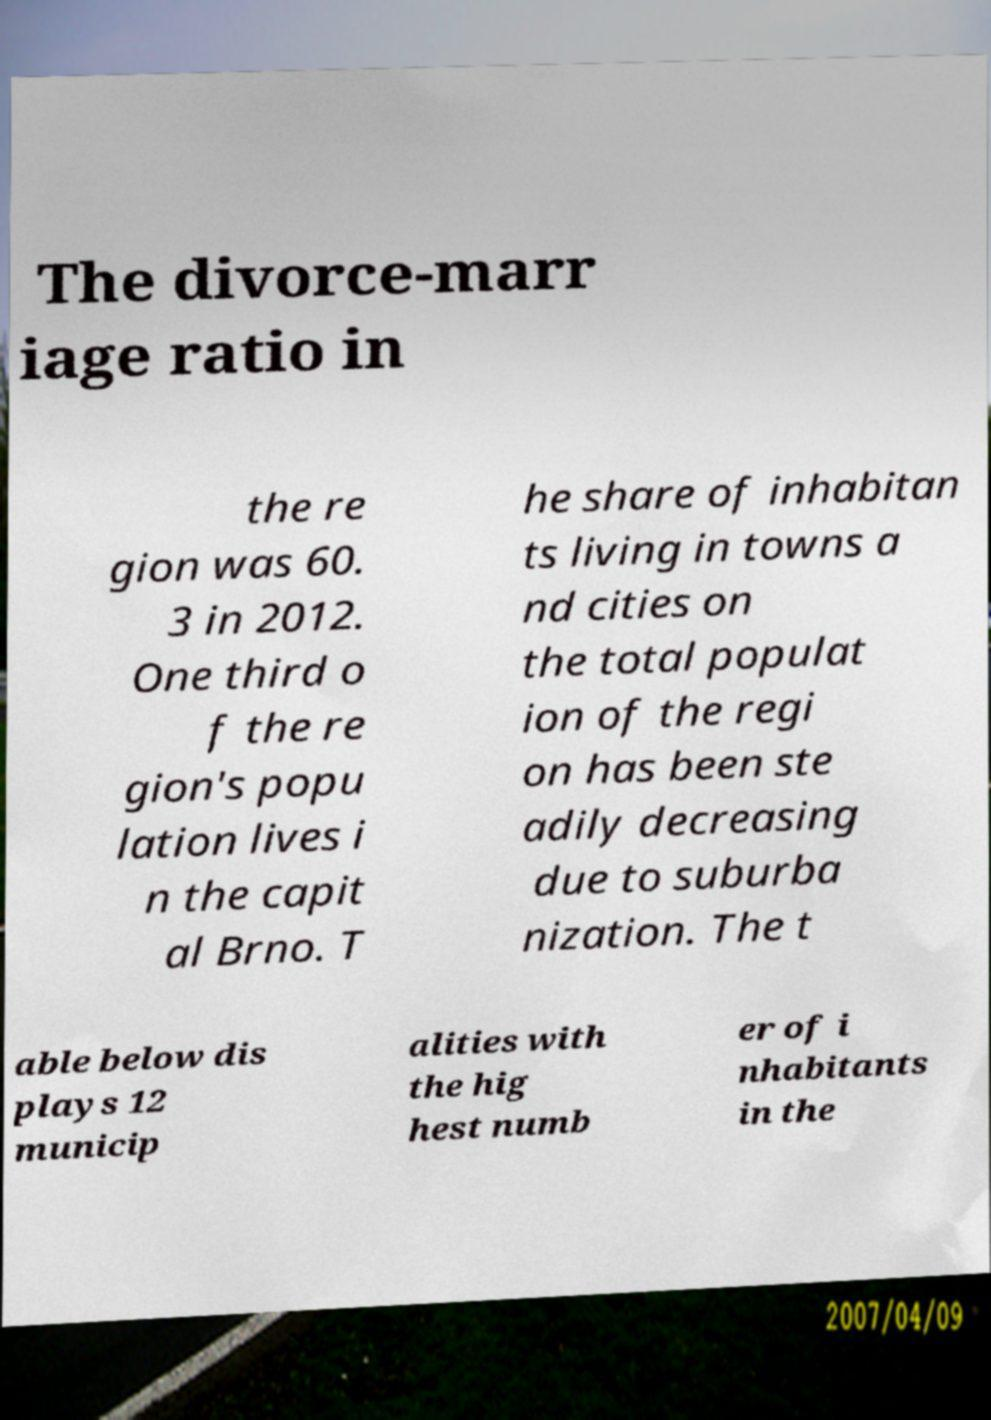For documentation purposes, I need the text within this image transcribed. Could you provide that? The divorce-marr iage ratio in the re gion was 60. 3 in 2012. One third o f the re gion's popu lation lives i n the capit al Brno. T he share of inhabitan ts living in towns a nd cities on the total populat ion of the regi on has been ste adily decreasing due to suburba nization. The t able below dis plays 12 municip alities with the hig hest numb er of i nhabitants in the 